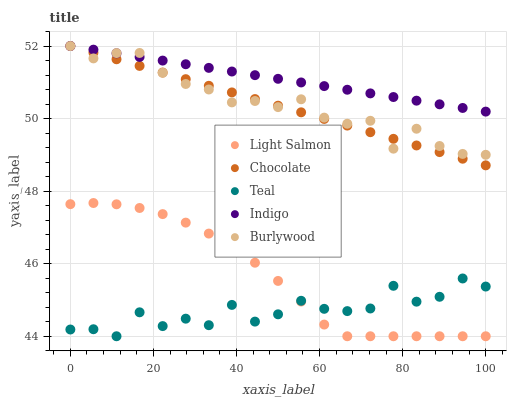Does Teal have the minimum area under the curve?
Answer yes or no. Yes. Does Indigo have the maximum area under the curve?
Answer yes or no. Yes. Does Light Salmon have the minimum area under the curve?
Answer yes or no. No. Does Light Salmon have the maximum area under the curve?
Answer yes or no. No. Is Indigo the smoothest?
Answer yes or no. Yes. Is Teal the roughest?
Answer yes or no. Yes. Is Light Salmon the smoothest?
Answer yes or no. No. Is Light Salmon the roughest?
Answer yes or no. No. Does Light Salmon have the lowest value?
Answer yes or no. Yes. Does Indigo have the lowest value?
Answer yes or no. No. Does Chocolate have the highest value?
Answer yes or no. Yes. Does Light Salmon have the highest value?
Answer yes or no. No. Is Light Salmon less than Burlywood?
Answer yes or no. Yes. Is Chocolate greater than Teal?
Answer yes or no. Yes. Does Light Salmon intersect Teal?
Answer yes or no. Yes. Is Light Salmon less than Teal?
Answer yes or no. No. Is Light Salmon greater than Teal?
Answer yes or no. No. Does Light Salmon intersect Burlywood?
Answer yes or no. No. 